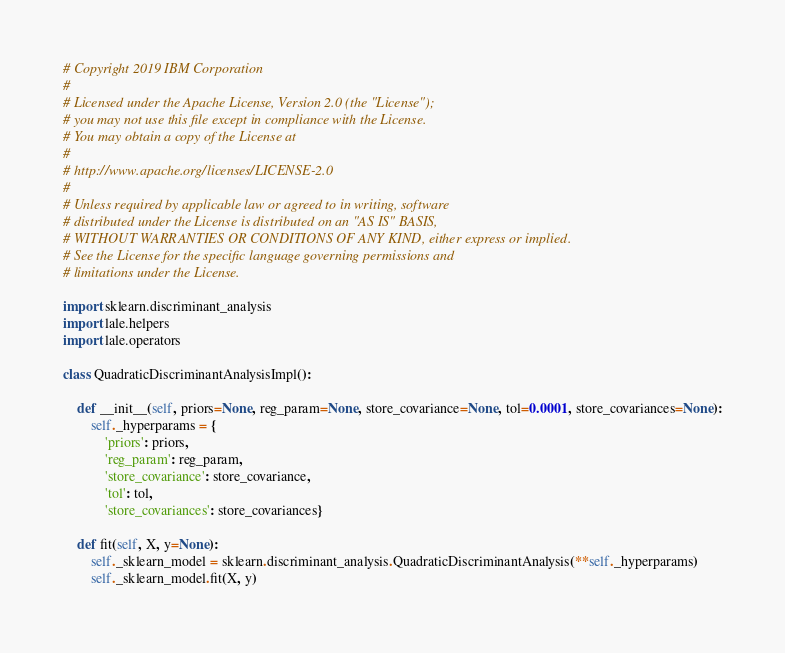<code> <loc_0><loc_0><loc_500><loc_500><_Python_># Copyright 2019 IBM Corporation
#
# Licensed under the Apache License, Version 2.0 (the "License");
# you may not use this file except in compliance with the License.
# You may obtain a copy of the License at
#
# http://www.apache.org/licenses/LICENSE-2.0
#
# Unless required by applicable law or agreed to in writing, software
# distributed under the License is distributed on an "AS IS" BASIS,
# WITHOUT WARRANTIES OR CONDITIONS OF ANY KIND, either express or implied.
# See the License for the specific language governing permissions and
# limitations under the License.

import sklearn.discriminant_analysis
import lale.helpers
import lale.operators

class QuadraticDiscriminantAnalysisImpl():

    def __init__(self, priors=None, reg_param=None, store_covariance=None, tol=0.0001, store_covariances=None):
        self._hyperparams = {
            'priors': priors,
            'reg_param': reg_param,
            'store_covariance': store_covariance,
            'tol': tol,
            'store_covariances': store_covariances}

    def fit(self, X, y=None):
        self._sklearn_model = sklearn.discriminant_analysis.QuadraticDiscriminantAnalysis(**self._hyperparams)
        self._sklearn_model.fit(X, y)</code> 